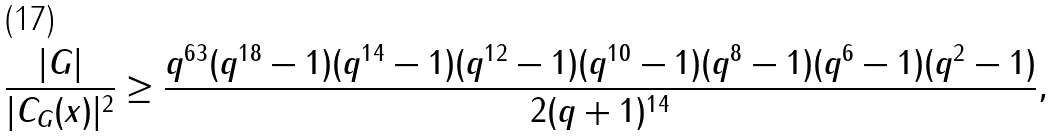<formula> <loc_0><loc_0><loc_500><loc_500>\frac { | G | } { | C _ { G } ( x ) | ^ { 2 } } \geq \frac { q ^ { 6 3 } ( q ^ { 1 8 } - 1 ) ( q ^ { 1 4 } - 1 ) ( q ^ { 1 2 } - 1 ) ( q ^ { 1 0 } - 1 ) ( q ^ { 8 } - 1 ) ( q ^ { 6 } - 1 ) ( q ^ { 2 } - 1 ) } { 2 ( q + 1 ) ^ { 1 4 } } ,</formula> 